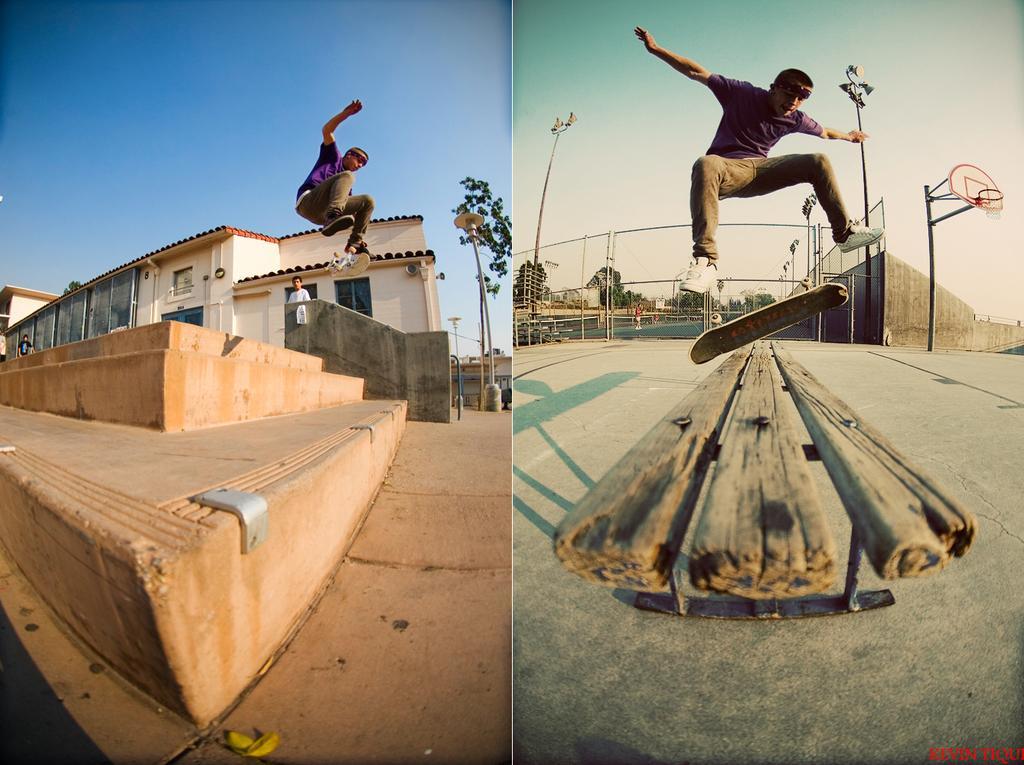Can you describe this image briefly? In this image I can see a person is doing kick flipping on a skateboard. This is a collage image of two different images. I can see buildings, people, trees and poles in both the images. I can see a football court in the right hand side image. 